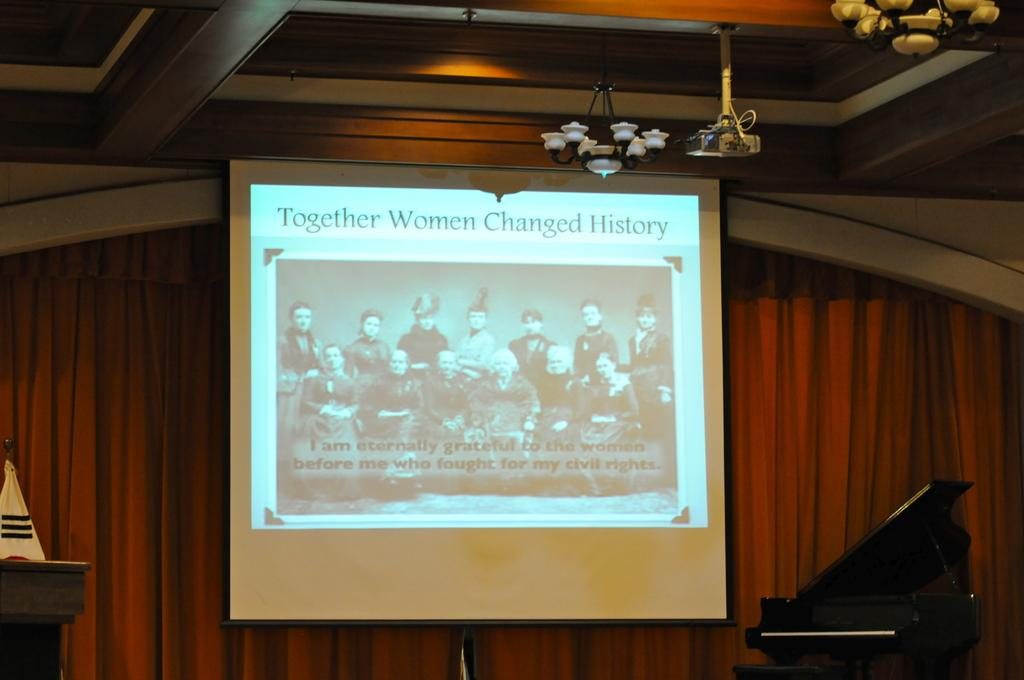What is the main feature of the image? There is a projector screen in the image. What is used to display images or videos on the screen? There is a projector in the image. What can be seen on the ceiling in the image? There are lights on the roof in the image. How many ants are crawling on the projector screen in the image? There are no ants visible on the projector screen in the image. What type of pie is being served on the table in the image? There is no table or pie present in the image. 